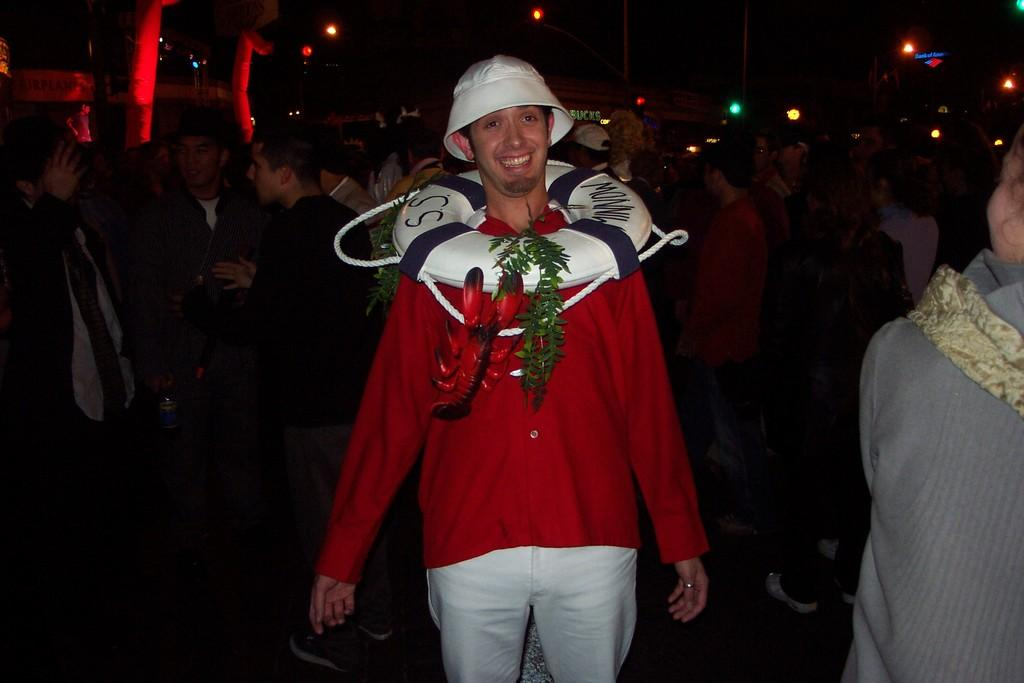What is the main subject of the image? There is a person in the image. What is the person wearing? The person is wearing a red shirt. What is the person's facial expression? The person is smiling. How many other people are visible in the image? There are many other persons visible in the image. What type of lighting is present in the image? Colorful lights are visible in the image. Can you see any deer in the image? No, there are no deer present in the image. What type of support is the person using in the image? There is no mention of any support being used by the person in the image. 